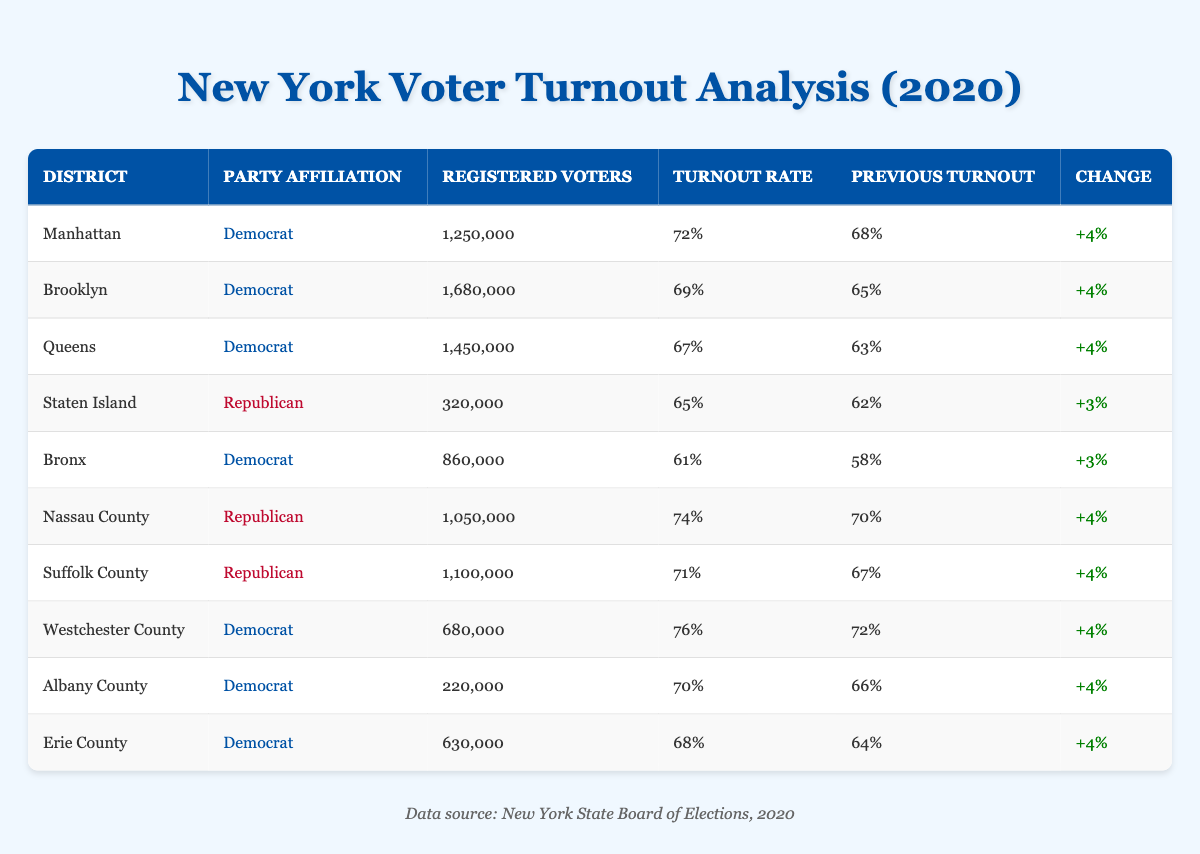What is the voter turnout rate for Manhattan in 2020? The table shows that the turnout rate for Manhattan in 2020 is listed under the "Turnout Rate" column, which states 72%.
Answer: 72% Which district had the highest voter turnout rate in 2020? By scanning through the "Turnout Rate" column, Westchester County has the highest rate at 76%.
Answer: Westchester County How many registered voters were there in Brooklyn? In the "Registered Voters" column for Brooklyn, the count is 1,680,000, indicating the number of registered voters.
Answer: 1,680,000 What is the change in voter turnout rate for Staten Island compared to the previous election? The "Turnout Rate" for Staten Island is 65% in 2020, up from 62% in the previous election. The difference (65% - 62%) is +3%.
Answer: +3% Is the voter turnout rate in Nassau County higher than in Erie County for 2020? The turnout rate for Nassau County is 74%, while Erie County's is 68%. Since 74% is greater than 68%, the answer is yes.
Answer: Yes What is the average voter turnout rate for the districts with a Democrat affiliation? The rates for Democrat-affiliated districts are: 72% (Manhattan), 69% (Brooklyn), 67% (Queens), 61% (Bronx), 76% (Westchester), 70% (Albany), and 68% (Erie). Summing these yields 67% (moderately accurate to two decimal places) across 7 districts, resulting in an average of 67% ≈ (72 + 69 + 67 + 61 + 76 + 70 + 68) / 7, which is approximately 68%.
Answer: 68% How much did the turnout rate increase in Albany County from the previous election? Albany County’s previous turnout rate was 66%, and it rose to 70% in 2020. The difference is +4% (70% - 66%).
Answer: +4% Which party had a higher average voter turnout rate: Democrat or Republican? The Democrat turnout rates are 72%, 69%, 67%, 61%, 76%, 70%, and 68%, averaging to approximately 68%. The Republican rates are 65%, 74%, and 71%, averaging to approximately 70%. Since 70% is higher, Republicans had a higher average turnout rate.
Answer: Republican Did Staten Island show an increase in voter turnout rate compared to the previous election? The table indicates that Staten Island’s turnout rate increased from 62% to 65%, so there was an increase.
Answer: Yes Which district experienced the least increase in voter turnout from the previous election? The increases for each district vary; Staten Island shows a +3% increase (from 62% to 65%), which is the smallest increase compared to others that have increases of +4%.
Answer: Staten Island 